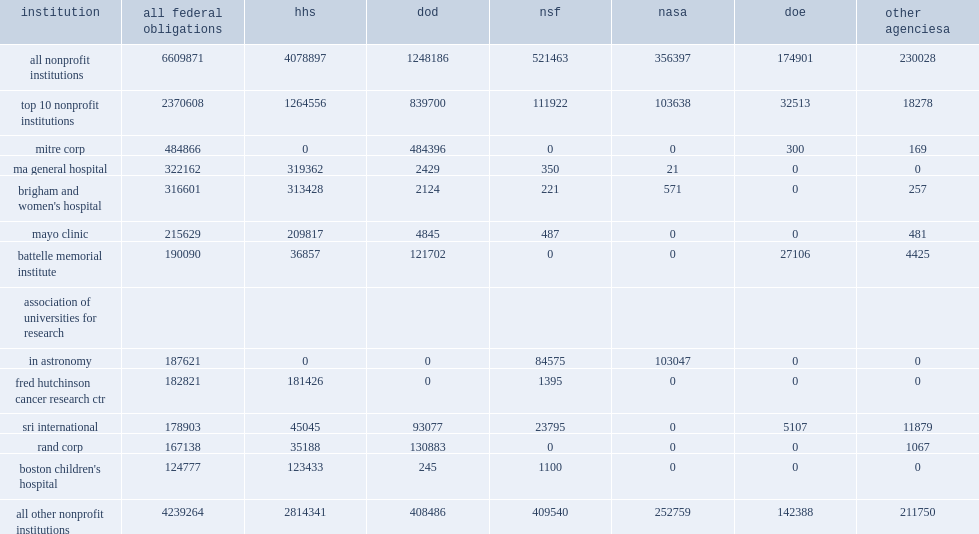During fy 2013, how many thousand dollars did federal agencies obligate to 1,068 nonprofit institutions? 6609871.0. How many thousand dollars did hhs account for the largest decrease in funding? 319362.0. How many thousand dollars did mitre corporation receive the most federal r&d and r&d plant funds among nonprofits in fy 2013? 484866.0. Mitre corporation received the most federal r&d and r&d plant funds ($485 million) among nonprofits in fy 2013, how many percent did dod provide of this funding? 0.999031. 